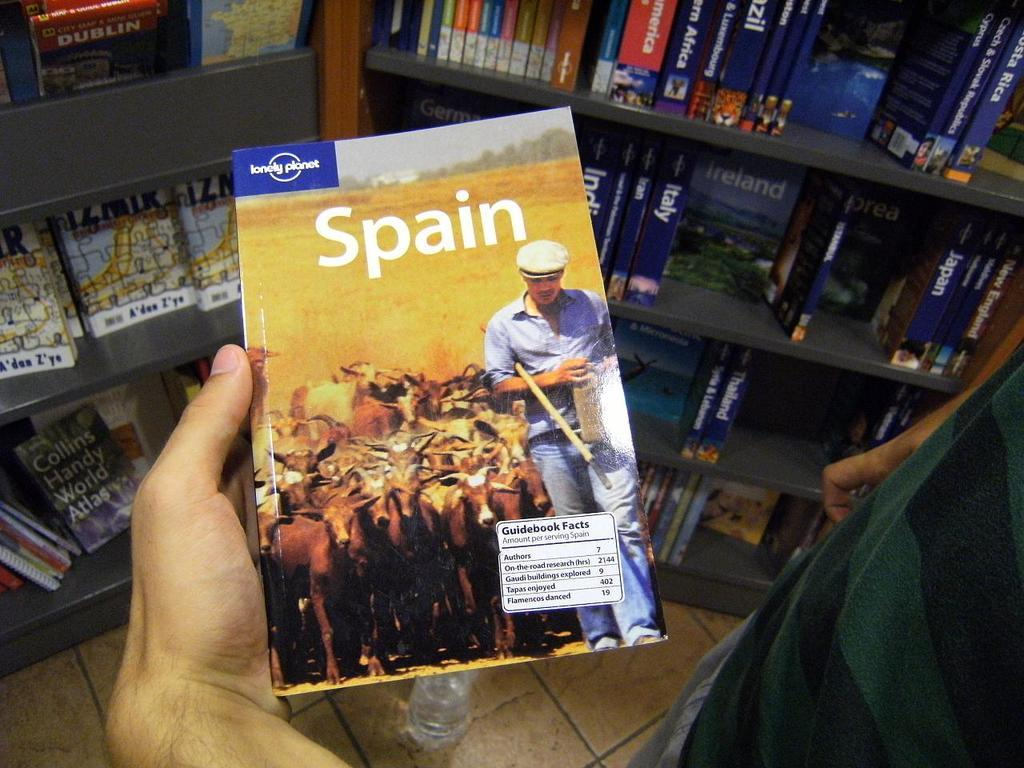<image>
Render a clear and concise summary of the photo. Someone holds a lonely Planet travel book about Spain. 